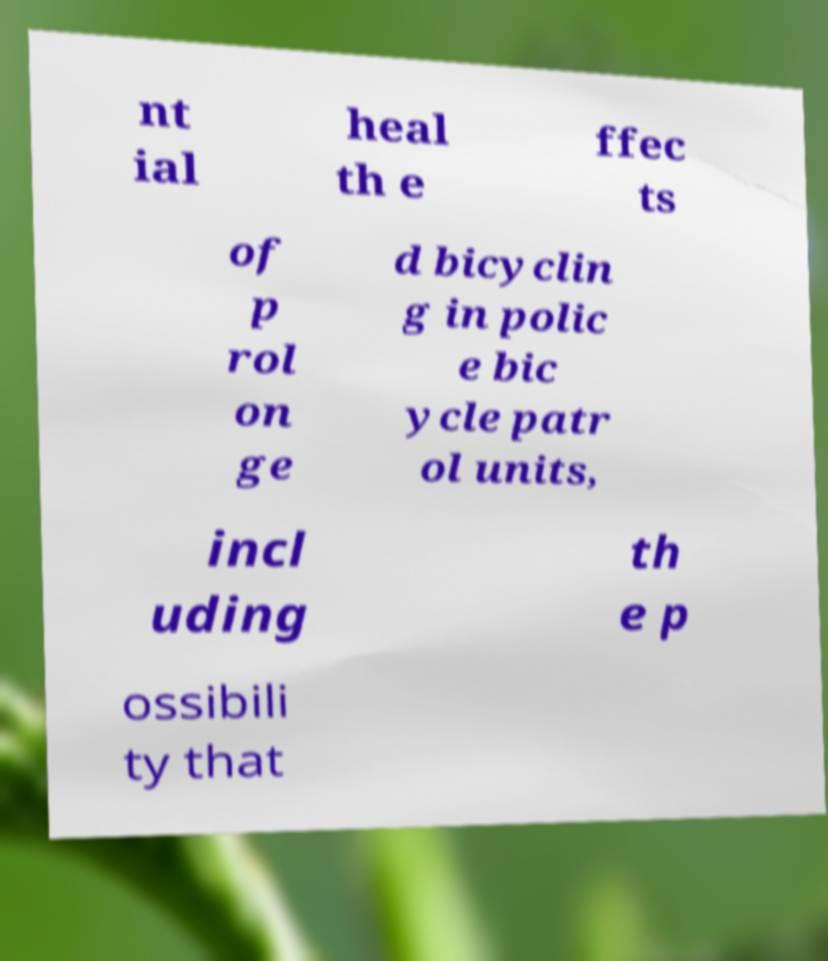I need the written content from this picture converted into text. Can you do that? nt ial heal th e ffec ts of p rol on ge d bicyclin g in polic e bic ycle patr ol units, incl uding th e p ossibili ty that 